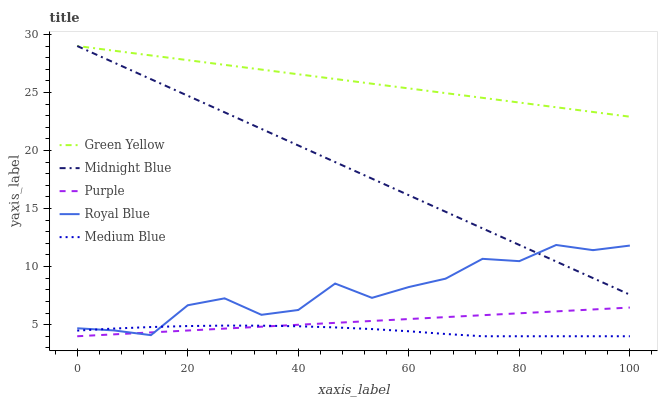Does Medium Blue have the minimum area under the curve?
Answer yes or no. Yes. Does Green Yellow have the maximum area under the curve?
Answer yes or no. Yes. Does Royal Blue have the minimum area under the curve?
Answer yes or no. No. Does Royal Blue have the maximum area under the curve?
Answer yes or no. No. Is Purple the smoothest?
Answer yes or no. Yes. Is Royal Blue the roughest?
Answer yes or no. Yes. Is Green Yellow the smoothest?
Answer yes or no. No. Is Green Yellow the roughest?
Answer yes or no. No. Does Royal Blue have the lowest value?
Answer yes or no. No. Does Midnight Blue have the highest value?
Answer yes or no. Yes. Does Royal Blue have the highest value?
Answer yes or no. No. Is Purple less than Midnight Blue?
Answer yes or no. Yes. Is Green Yellow greater than Royal Blue?
Answer yes or no. Yes. Does Purple intersect Midnight Blue?
Answer yes or no. No. 